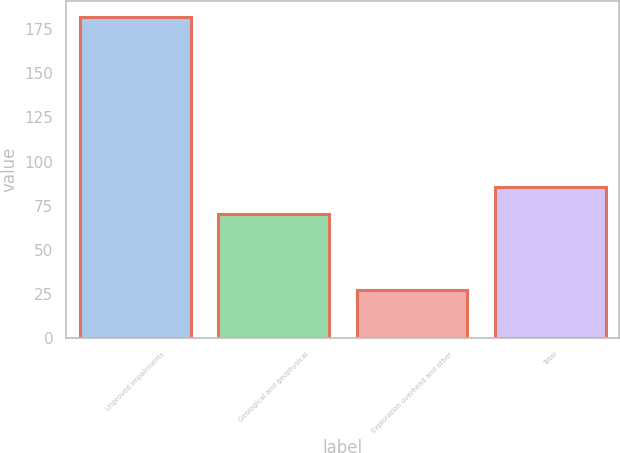Convert chart to OTSL. <chart><loc_0><loc_0><loc_500><loc_500><bar_chart><fcel>Unproved impairments<fcel>Geological and geophysical<fcel>Exploration overhead and other<fcel>Total<nl><fcel>182<fcel>70<fcel>27<fcel>85.5<nl></chart> 